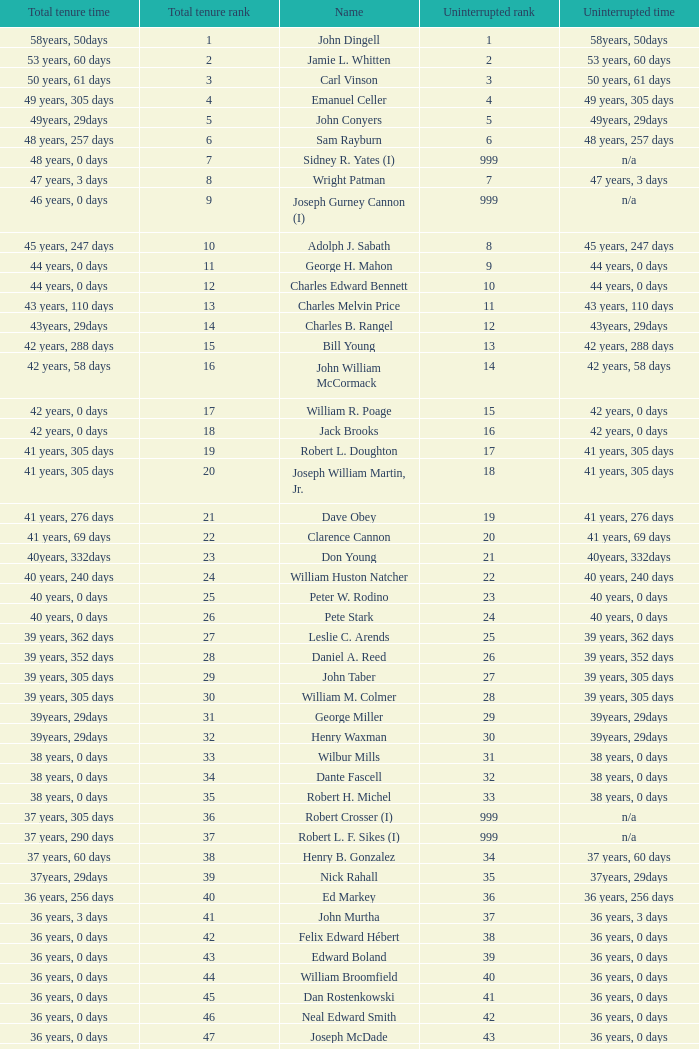How many uninterrupted ranks does john dingell have? 1.0. 